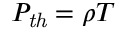<formula> <loc_0><loc_0><loc_500><loc_500>P _ { t h } = \rho T</formula> 